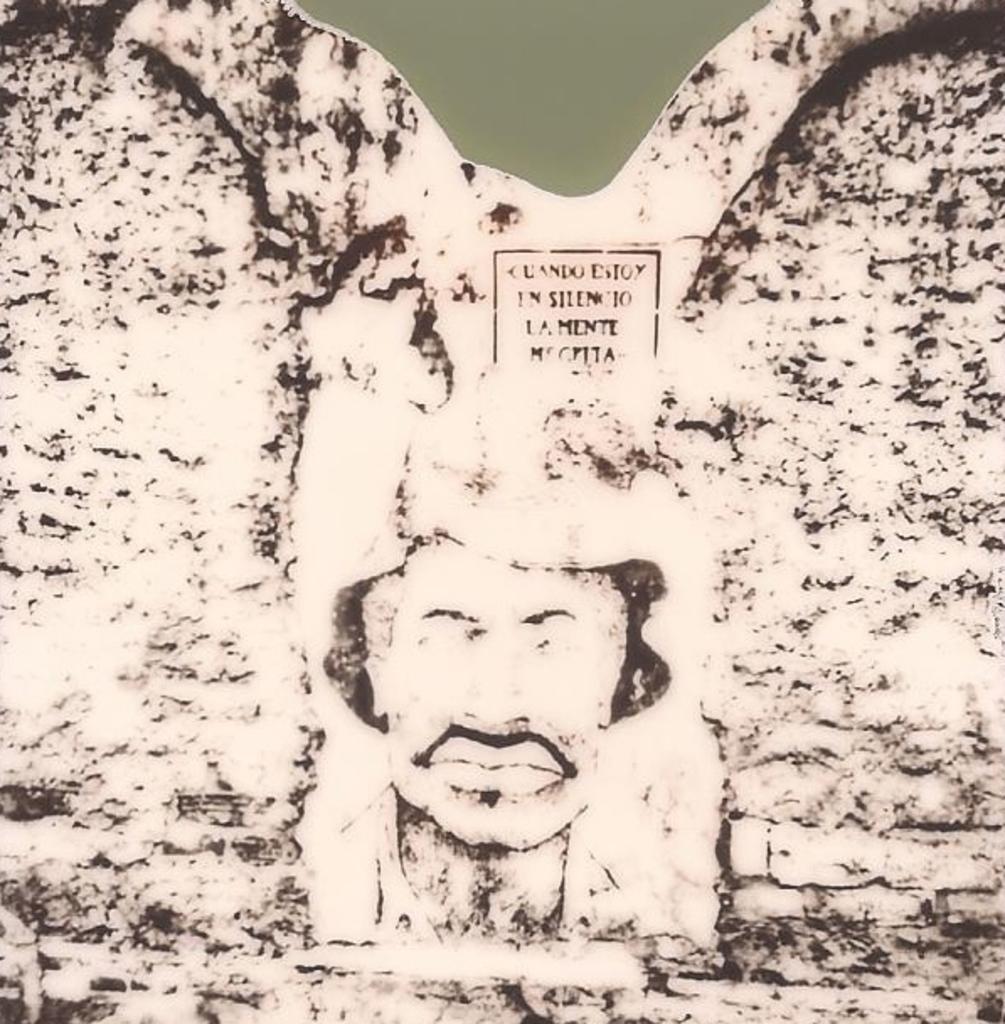Please provide a concise description of this image. In this picture we can see the wall and on this wall we can see a face of a person and some text. 